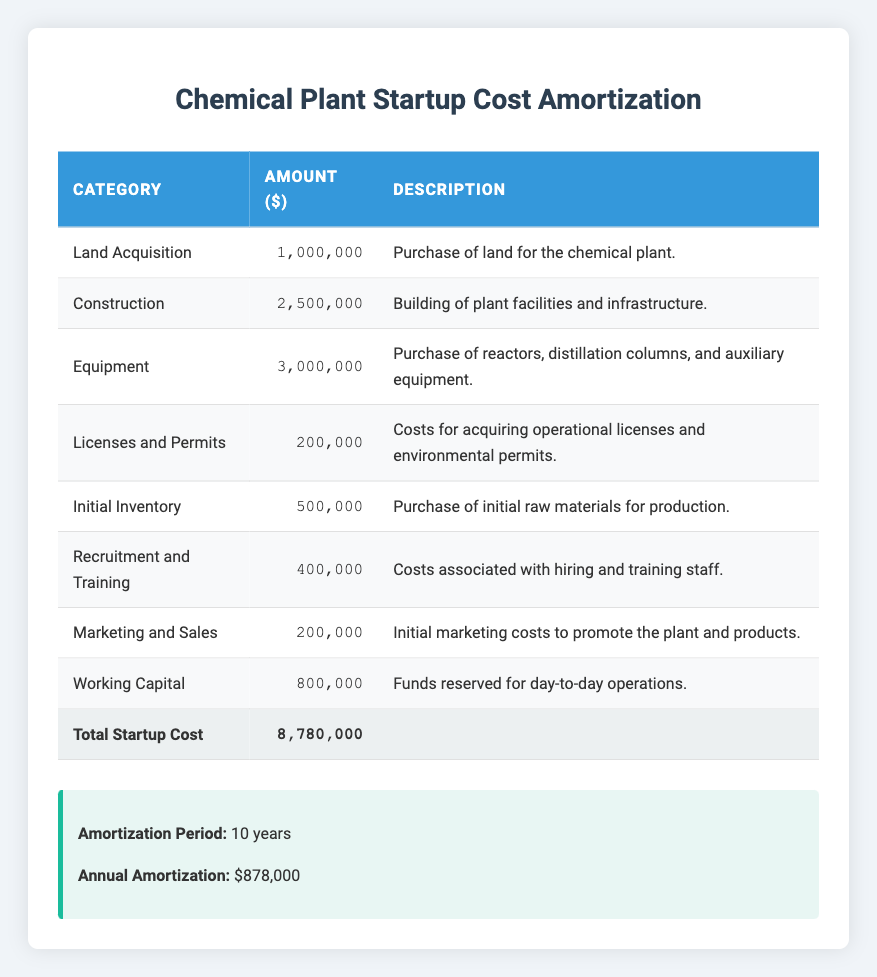What is the total amount for construction costs? The construction costs are directly listed in the table under the "Construction" category, which shows an amount of 2,500,000.
Answer: 2,500,000 How much is allocated for equipment? The amount allocated for equipment is clearly stated in the table under the "Equipment" category, which is 3,000,000.
Answer: 3,000,000 Is the total startup cost more than 8 million? The total startup cost is presented at the bottom of the table and is 8,780,000, which is greater than 8 million.
Answer: Yes What is the total amount for recruitment and training plus marketing and sales? To find the total, we need to add the amounts from both the "Recruitment and Training" category (400,000) and the "Marketing and Sales" category (200,000). Thus, 400,000 + 200,000 = 600,000.
Answer: 600,000 What is the average cost of the categories listed in the startup costs? First, we sum all the startup costs: 1,000,000 + 2,500,000 + 3,000,000 + 200,000 + 500,000 + 400,000 + 200,000 + 800,000 = 8,780,000. There are 8 categories, so the average is 8,780,000 / 8 = 1,097,500.
Answer: 1,097,500 What percentage of the total startup cost is allocated for licenses and permits? The amount for licenses and permits is 200,000. To find the percentage, we calculate (200,000 / 8,780,000) * 100, which gives us approximately 2.27%.
Answer: 2.27% Is the amount for working capital higher than the amount for initial inventory? The amount for working capital is shown as 800,000, while the amount for initial inventory is 500,000. Since 800,000 is greater than 500,000, the answer is yes.
Answer: Yes How much more is spent on equipment than on licenses and permits? The amount spent on equipment is 3,000,000 and on licenses and permits it is 200,000. The difference is calculated by finding 3,000,000 - 200,000, resulting in 2,800,000.
Answer: 2,800,000 